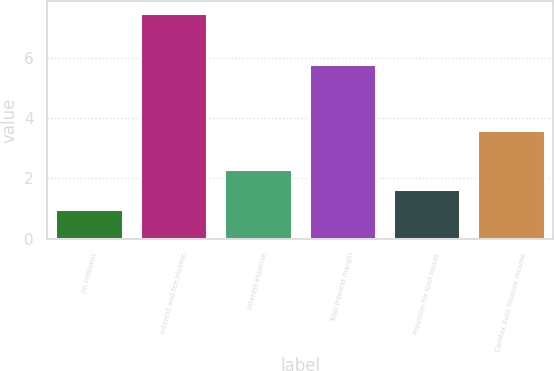Convert chart to OTSL. <chart><loc_0><loc_0><loc_500><loc_500><bar_chart><fcel>(In millions)<fcel>Interest and fee income<fcel>Interest expense<fcel>Total interest margin<fcel>Provision for loan losses<fcel>CarMax Auto Finance income<nl><fcel>1<fcel>7.5<fcel>2.3<fcel>5.8<fcel>1.65<fcel>3.6<nl></chart> 